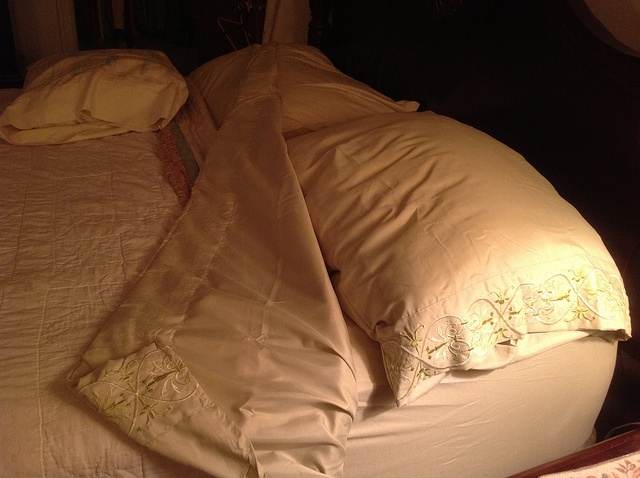Describe the objects in this image and their specific colors. I can see a bed in maroon, black, brown, and gray tones in this image. 